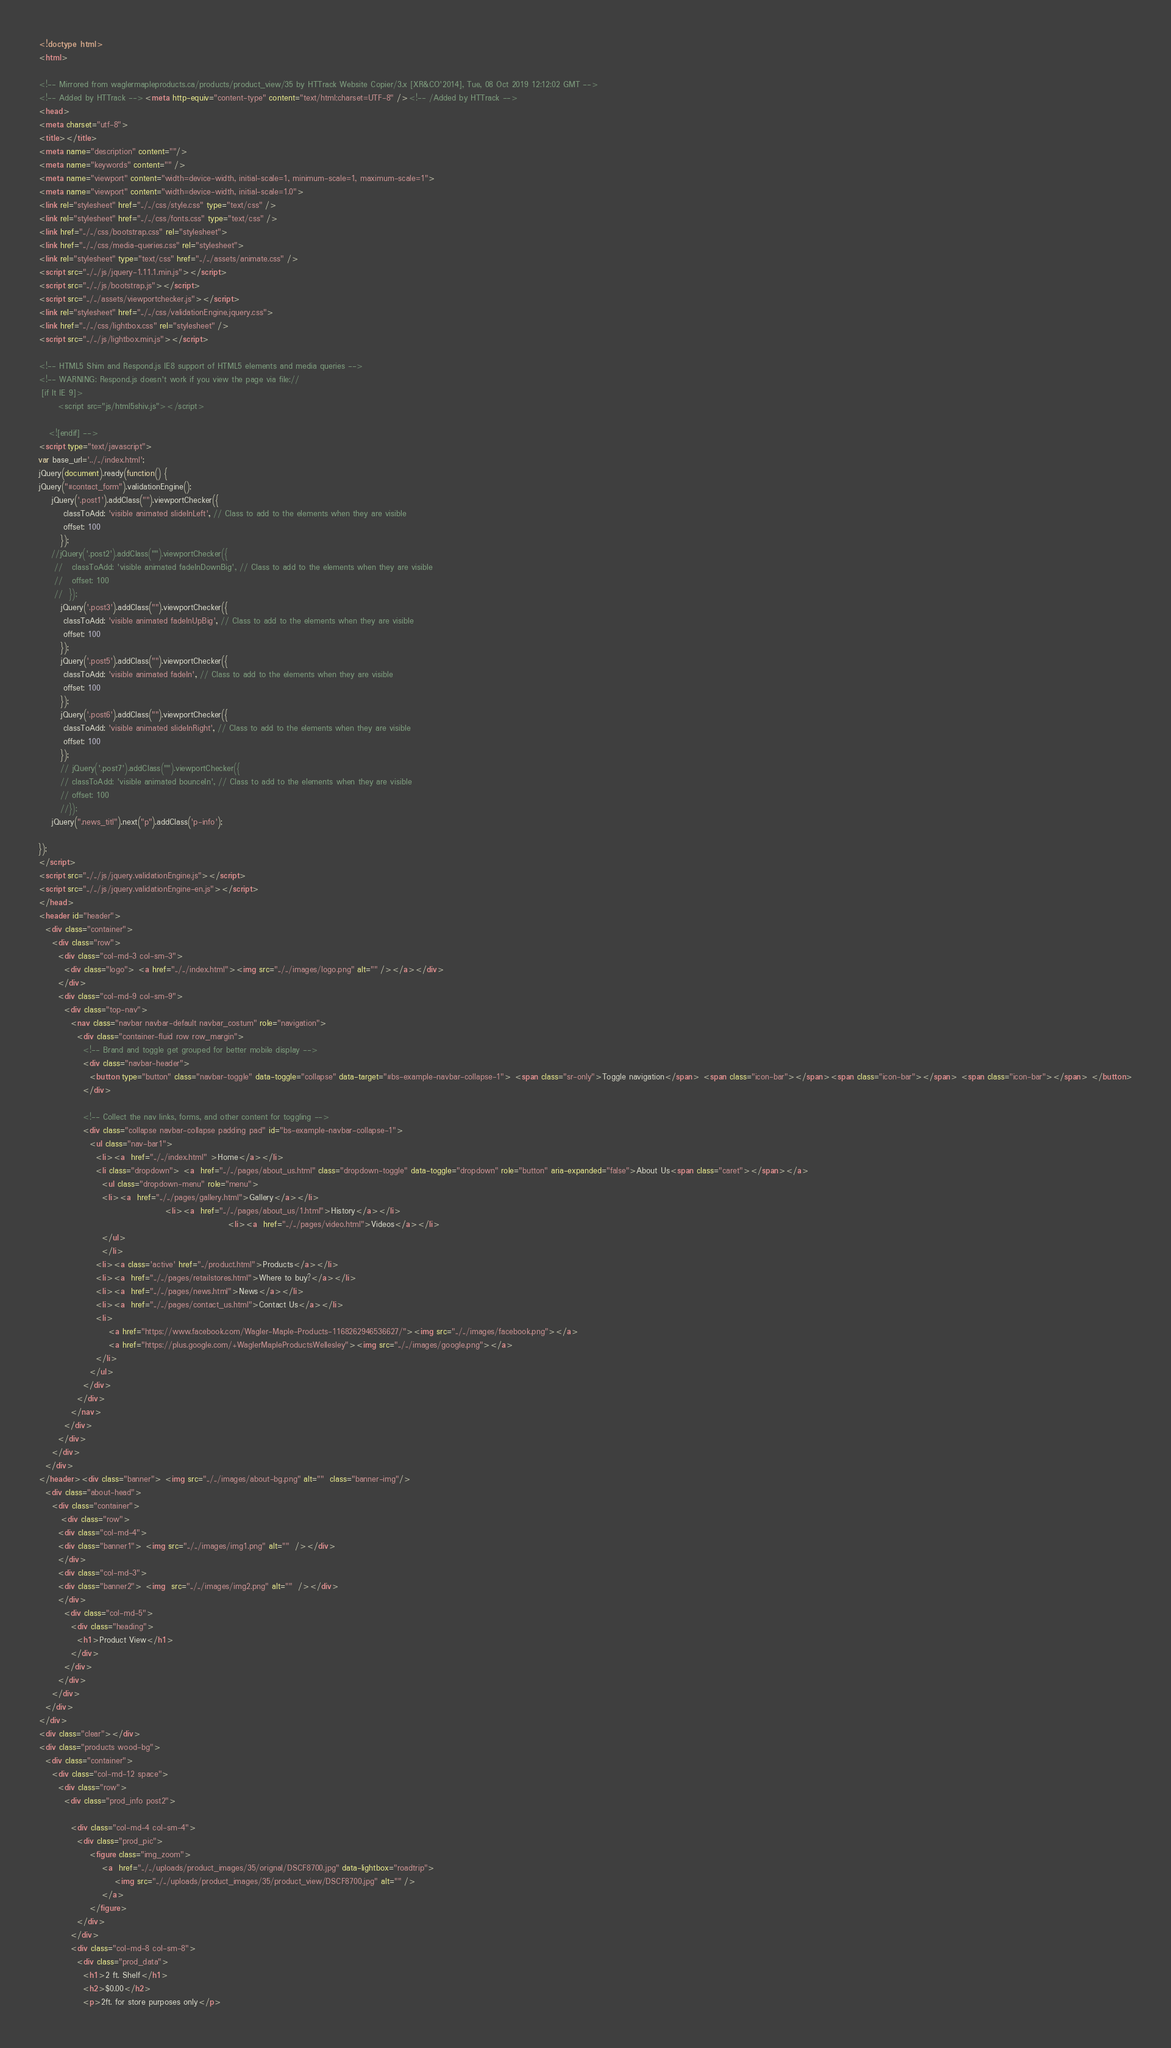Convert code to text. <code><loc_0><loc_0><loc_500><loc_500><_HTML_><!doctype html>
<html>

<!-- Mirrored from waglermapleproducts.ca/products/product_view/35 by HTTrack Website Copier/3.x [XR&CO'2014], Tue, 08 Oct 2019 12:12:02 GMT -->
<!-- Added by HTTrack --><meta http-equiv="content-type" content="text/html;charset=UTF-8" /><!-- /Added by HTTrack -->
<head>
<meta charset="utf-8">
<title></title>
<meta name="description" content=""/>
<meta name="keywords" content="" />
<meta name="viewport" content="width=device-width, initial-scale=1, minimum-scale=1, maximum-scale=1">
<meta name="viewport" content="width=device-width, initial-scale=1.0">
<link rel="stylesheet" href="../../css/style.css" type="text/css" />
<link rel="stylesheet" href="../../css/fonts.css" type="text/css" />
<link href="../../css/bootstrap.css" rel="stylesheet">
<link href="../../css/media-queries.css" rel="stylesheet">
<link rel="stylesheet" type="text/css" href="../../assets/animate.css" />
<script src="../../js/jquery-1.11.1.min.js"></script>
<script src="../../js/bootstrap.js"></script>
<script src="../../assets/viewportchecker.js"></script>
<link rel="stylesheet" href="../../css/validationEngine.jquery.css"> 
<link href="../../css/lightbox.css" rel="stylesheet" />
<script src="../../js/lightbox.min.js"></script>

<!-- HTML5 Shim and Respond.js IE8 support of HTML5 elements and media queries -->
<!-- WARNING: Respond.js doesn't work if you view the page via file:// 
 [if lt IE 9]> 
      <script src="js/html5shiv.js"></script>
           
   <![endif] -->
<script type="text/javascript">
var base_url='../../index.html';
jQuery(document).ready(function() {
jQuery("#contact_form").validationEngine();
	jQuery('.post1').addClass("").viewportChecker({
	    classToAdd: 'visible animated slideInLeft', // Class to add to the elements when they are visible
	    offset: 100    
	   });
	//jQuery('.post2').addClass("").viewportChecker({
	 //   classToAdd: 'visible animated fadeInDownBig', // Class to add to the elements when they are visible
	 //   offset: 100    
	 //  });
	   jQuery('.post3').addClass("").viewportChecker({
	    classToAdd: 'visible animated fadeInUpBig', // Class to add to the elements when they are visible
	    offset: 100    
	   });
	   jQuery('.post5').addClass("").viewportChecker({
	    classToAdd: 'visible animated fadeIn', // Class to add to the elements when they are visible
	    offset: 100    
	   });
	   jQuery('.post6').addClass("").viewportChecker({
	    classToAdd: 'visible animated slideInRight', // Class to add to the elements when they are visible
	    offset: 100    
	   });
	   // jQuery('.post7').addClass("").viewportChecker({
	   // classToAdd: 'visible animated bounceIn', // Class to add to the elements when they are visible
	   // offset: 100    
	   //});
	jQuery(".news_titl").next("p").addClass('p-info');
	   
});            
</script>
<script src="../../js/jquery.validationEngine.js"></script>
<script src="../../js/jquery.validationEngine-en.js"></script>
</head>
<header id="header">
  <div class="container">
    <div class="row">
      <div class="col-md-3 col-sm-3">
        <div class="logo"> <a href="../../index.html"><img src="../../images/logo.png" alt="" /></a></div>
      </div>
      <div class="col-md-9 col-sm-9">
        <div class="top-nav">
          <nav class="navbar navbar-default navbar_costum" role="navigation">
            <div class="container-fluid row row_margin"> 
              <!-- Brand and toggle get grouped for better mobile display -->
              <div class="navbar-header">
                <button type="button" class="navbar-toggle" data-toggle="collapse" data-target="#bs-example-navbar-collapse-1"> <span class="sr-only">Toggle navigation</span> <span class="icon-bar"></span><span class="icon-bar"></span> <span class="icon-bar"></span> </button>
              </div>
              
              <!-- Collect the nav links, forms, and other content for toggling -->
              <div class="collapse navbar-collapse padding pad" id="bs-example-navbar-collapse-1">
                <ul class="nav-bar1">
                  <li><a  href="../../index.html" >Home</a></li>
				  <li class="dropdown"> <a  href="../../pages/about_us.html" class="dropdown-toggle" data-toggle="dropdown" role="button" aria-expanded="false">About Us<span class="caret"></span></a>
					<ul class="dropdown-menu" role="menu">
					<li><a  href="../../pages/gallery.html">Gallery</a></li>
										<li><a  href="../../pages/about_us/1.html">History</a></li>
					                                        <li><a  href="../../pages/video.html">Videos</a></li>
					</ul>
					</li>
                  <li><a class='active' href="../product.html">Products</a></li>
                  <li><a  href="../../pages/retailstores.html">Where to buy?</a></li>
                  <li><a  href="../../pages/news.html">News</a></li>
                  <li><a  href="../../pages/contact_us.html">Contact Us</a></li>
                  <li>
                      <a href="https://www.facebook.com/Wagler-Maple-Products-1168262946536627/"><img src="../../images/facebook.png"></a>
                      <a href="https://plus.google.com/+WaglerMapleProductsWellesley"><img src="../../images/google.png"></a>
                  </li>
                </ul>
              </div>
            </div>
          </nav>
        </div>
      </div>
    </div>
  </div>
</header><div class="banner"> <img src="../../images/about-bg.png" alt=""  class="banner-img"/>
  <div class="about-head">
    <div class="container">
       <div class="row">
	  <div class="col-md-4">
	  <div class="banner1"> <img src="../../images/img1.png" alt=""  /></div>
	  </div>
	  <div class="col-md-3">
	  <div class="banner2"> <img  src="../../images/img2.png" alt=""  /></div>
	  </div>
        <div class="col-md-5">
          <div class="heading">
            <h1>Product View</h1>
          </div>
        </div>
      </div>
    </div>
  </div>
</div>
<div class="clear"></div>
<div class="products wood-bg">
  <div class="container">
    <div class="col-md-12 space">
      <div class="row">
        <div class="prod_info post2">
            
          <div class="col-md-4 col-sm-4">
            <div class="prod_pic">
				<figure class="img_zoom">
					<a  href="../../uploads/product_images/35/orignal/DSCF8700.jpg" data-lightbox="roadtrip">
						<img src="../../uploads/product_images/35/product_view/DSCF8700.jpg" alt="" />
					</a>	
				</figure>
            </div>
          </div>
          <div class="col-md-8 col-sm-8">
            <div class="prod_data">
              <h1>2 ft. Shelf</h1>
              <h2>$0.00</h2>
              <p>2ft. for store purposes only</p></code> 